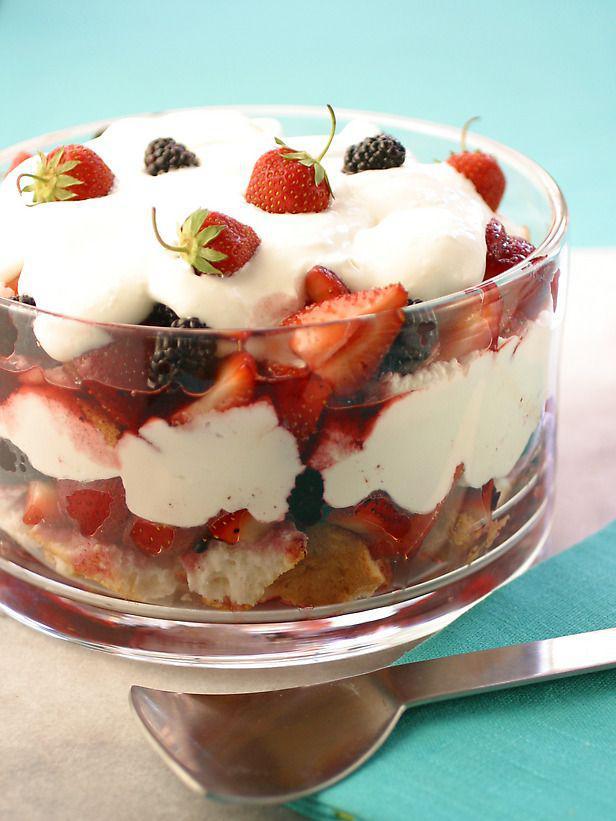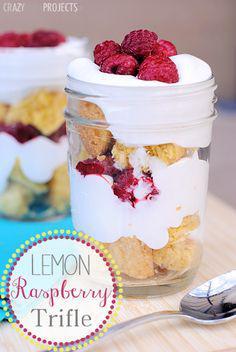The first image is the image on the left, the second image is the image on the right. For the images shown, is this caption "A banana is shown near at least one of the desserts." true? Answer yes or no. No. The first image is the image on the left, the second image is the image on the right. Considering the images on both sides, is "An image shows a whipped cream-topped dessert in a jar next to unpeeled bananas." valid? Answer yes or no. No. 